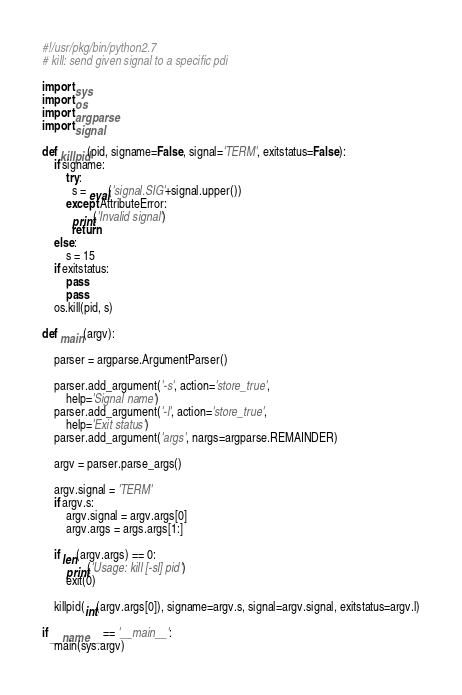<code> <loc_0><loc_0><loc_500><loc_500><_Python_>#!/usr/pkg/bin/python2.7
# kill: send given signal to a specific pdi

import sys
import os
import argparse
import signal

def killpid(pid, signame=False, signal='TERM', exitstatus=False):
    if signame:
        try:
          s = eval('signal.SIG'+signal.upper())
        except AttributeError:
          print('Invalid signal')
          return
    else:
        s = 15
    if exitstatus:
        pass
        pass
    os.kill(pid, s)

def main(argv):

    parser = argparse.ArgumentParser()

    parser.add_argument('-s', action='store_true',
        help='Signal name')
    parser.add_argument('-l', action='store_true',
        help='Exit status')
    parser.add_argument('args', nargs=argparse.REMAINDER)

    argv = parser.parse_args()

    argv.signal = 'TERM'
    if argv.s:
        argv.signal = argv.args[0]
        argv.args = args.args[1:]

    if len(argv.args) == 0:
        print('Usage: kill [-sl] pid')
        exit(0)

    killpid(int(argv.args[0]), signame=argv.s, signal=argv.signal, exitstatus=argv.l)

if __name__ == '__main__':
    main(sys.argv)
</code> 